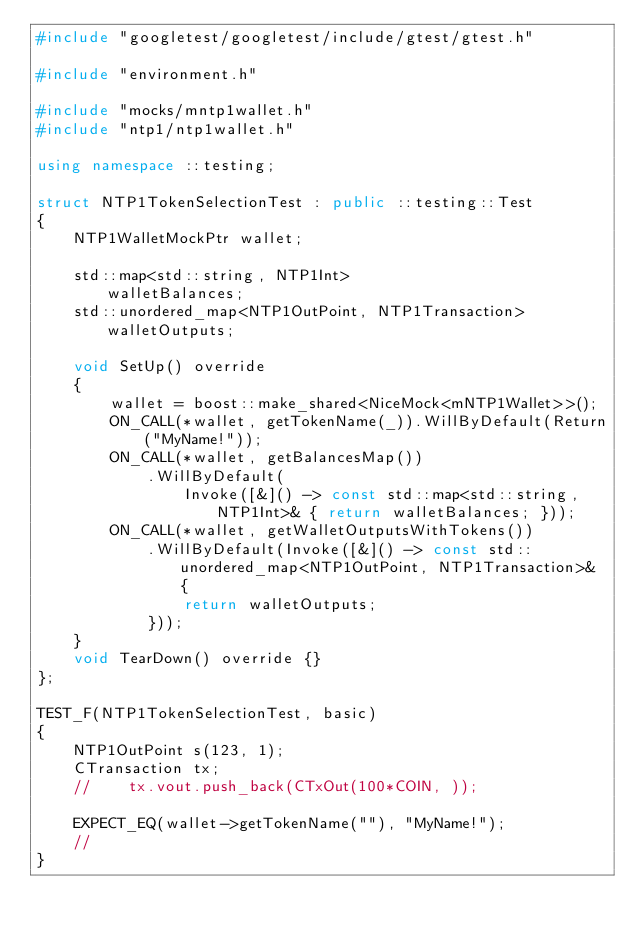Convert code to text. <code><loc_0><loc_0><loc_500><loc_500><_C++_>#include "googletest/googletest/include/gtest/gtest.h"

#include "environment.h"

#include "mocks/mntp1wallet.h"
#include "ntp1/ntp1wallet.h"

using namespace ::testing;

struct NTP1TokenSelectionTest : public ::testing::Test
{
    NTP1WalletMockPtr wallet;

    std::map<std::string, NTP1Int>                    walletBalances;
    std::unordered_map<NTP1OutPoint, NTP1Transaction> walletOutputs;

    void SetUp() override
    {
        wallet = boost::make_shared<NiceMock<mNTP1Wallet>>();
        ON_CALL(*wallet, getTokenName(_)).WillByDefault(Return("MyName!"));
        ON_CALL(*wallet, getBalancesMap())
            .WillByDefault(
                Invoke([&]() -> const std::map<std::string, NTP1Int>& { return walletBalances; }));
        ON_CALL(*wallet, getWalletOutputsWithTokens())
            .WillByDefault(Invoke([&]() -> const std::unordered_map<NTP1OutPoint, NTP1Transaction>& {
                return walletOutputs;
            }));
    }
    void TearDown() override {}
};

TEST_F(NTP1TokenSelectionTest, basic)
{
    NTP1OutPoint s(123, 1);
    CTransaction tx;
    //    tx.vout.push_back(CTxOut(100*COIN, ));

    EXPECT_EQ(wallet->getTokenName(""), "MyName!");
    //
}
</code> 